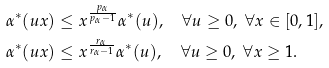Convert formula to latex. <formula><loc_0><loc_0><loc_500><loc_500>\alpha ^ { * } ( u x ) & \leq x ^ { \frac { p _ { \alpha } } { p _ { \alpha } - 1 } } \alpha ^ { * } ( u ) , \quad \forall u \geq 0 , \ \forall x \in [ 0 , 1 ] , \\ \alpha ^ { * } ( u x ) & \leq x ^ { \frac { r _ { \alpha } } { r _ { \alpha } - 1 } } \alpha ^ { * } ( u ) , \quad \forall u \geq 0 , \ \forall x \geq 1 .</formula> 